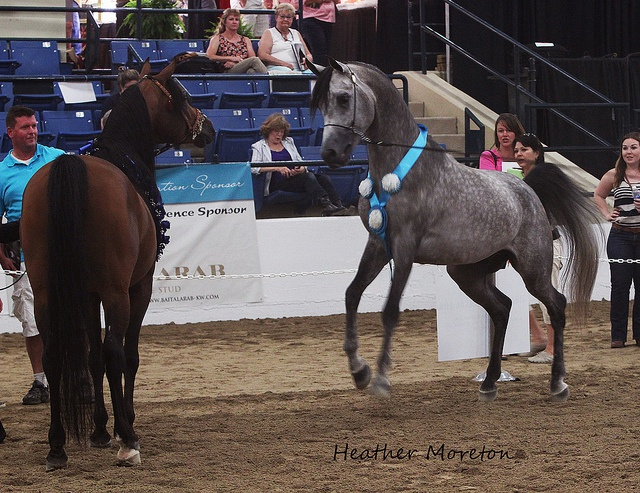Describe the objects in this image and their specific colors. I can see horse in darkgray, black, and gray tones, horse in darkgray, black, maroon, and gray tones, people in darkgray, black, maroon, lightblue, and gray tones, people in darkgray, black, and gray tones, and people in darkgray, black, gray, maroon, and lightgray tones in this image. 